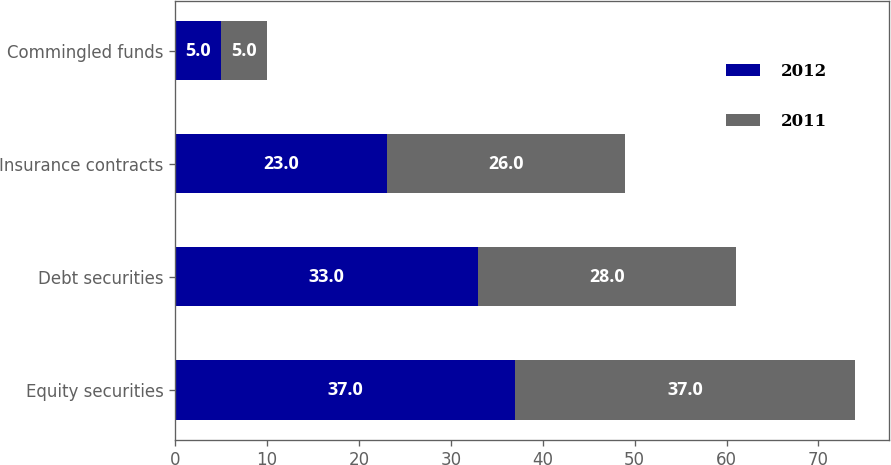<chart> <loc_0><loc_0><loc_500><loc_500><stacked_bar_chart><ecel><fcel>Equity securities<fcel>Debt securities<fcel>Insurance contracts<fcel>Commingled funds<nl><fcel>2012<fcel>37<fcel>33<fcel>23<fcel>5<nl><fcel>2011<fcel>37<fcel>28<fcel>26<fcel>5<nl></chart> 